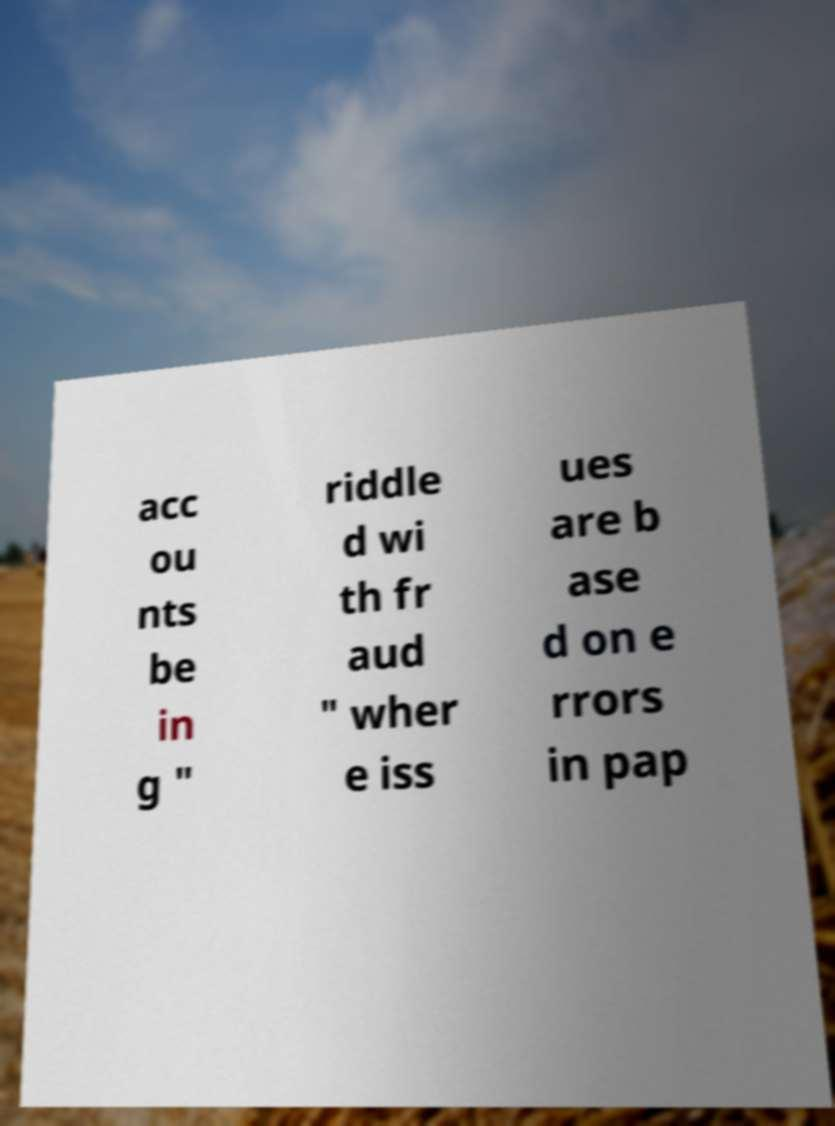For documentation purposes, I need the text within this image transcribed. Could you provide that? acc ou nts be in g " riddle d wi th fr aud " wher e iss ues are b ase d on e rrors in pap 